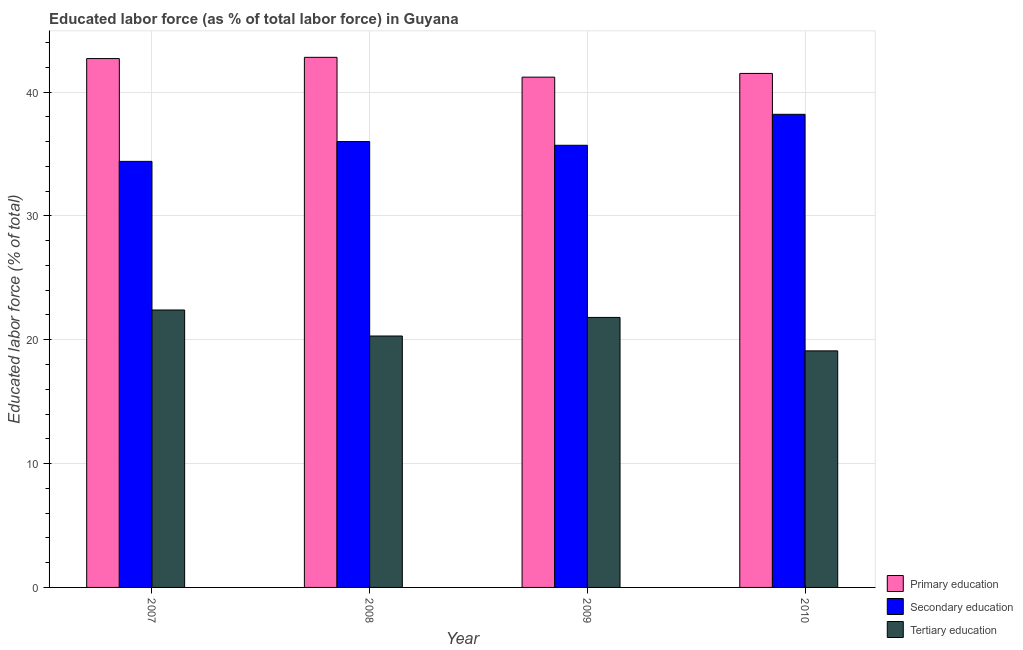How many groups of bars are there?
Your response must be concise. 4. Are the number of bars per tick equal to the number of legend labels?
Provide a short and direct response. Yes. How many bars are there on the 1st tick from the right?
Give a very brief answer. 3. What is the percentage of labor force who received tertiary education in 2008?
Keep it short and to the point. 20.3. Across all years, what is the maximum percentage of labor force who received secondary education?
Provide a succinct answer. 38.2. Across all years, what is the minimum percentage of labor force who received primary education?
Keep it short and to the point. 41.2. In which year was the percentage of labor force who received tertiary education minimum?
Your answer should be very brief. 2010. What is the total percentage of labor force who received primary education in the graph?
Your response must be concise. 168.2. What is the difference between the percentage of labor force who received tertiary education in 2007 and the percentage of labor force who received primary education in 2010?
Provide a succinct answer. 3.3. What is the average percentage of labor force who received secondary education per year?
Keep it short and to the point. 36.08. In the year 2010, what is the difference between the percentage of labor force who received tertiary education and percentage of labor force who received primary education?
Give a very brief answer. 0. What is the ratio of the percentage of labor force who received secondary education in 2007 to that in 2010?
Provide a short and direct response. 0.9. Is the difference between the percentage of labor force who received secondary education in 2009 and 2010 greater than the difference between the percentage of labor force who received primary education in 2009 and 2010?
Offer a very short reply. No. What is the difference between the highest and the second highest percentage of labor force who received primary education?
Your answer should be very brief. 0.1. What is the difference between the highest and the lowest percentage of labor force who received tertiary education?
Give a very brief answer. 3.3. In how many years, is the percentage of labor force who received tertiary education greater than the average percentage of labor force who received tertiary education taken over all years?
Keep it short and to the point. 2. Is the sum of the percentage of labor force who received secondary education in 2008 and 2009 greater than the maximum percentage of labor force who received tertiary education across all years?
Your response must be concise. Yes. What does the 1st bar from the left in 2009 represents?
Ensure brevity in your answer.  Primary education. What does the 1st bar from the right in 2010 represents?
Your response must be concise. Tertiary education. Is it the case that in every year, the sum of the percentage of labor force who received primary education and percentage of labor force who received secondary education is greater than the percentage of labor force who received tertiary education?
Make the answer very short. Yes. How many bars are there?
Ensure brevity in your answer.  12. Are all the bars in the graph horizontal?
Your response must be concise. No. How many years are there in the graph?
Make the answer very short. 4. What is the difference between two consecutive major ticks on the Y-axis?
Your answer should be very brief. 10. Does the graph contain grids?
Your answer should be very brief. Yes. How many legend labels are there?
Offer a terse response. 3. What is the title of the graph?
Offer a very short reply. Educated labor force (as % of total labor force) in Guyana. What is the label or title of the X-axis?
Provide a short and direct response. Year. What is the label or title of the Y-axis?
Your response must be concise. Educated labor force (% of total). What is the Educated labor force (% of total) of Primary education in 2007?
Offer a very short reply. 42.7. What is the Educated labor force (% of total) in Secondary education in 2007?
Offer a terse response. 34.4. What is the Educated labor force (% of total) in Tertiary education in 2007?
Make the answer very short. 22.4. What is the Educated labor force (% of total) in Primary education in 2008?
Make the answer very short. 42.8. What is the Educated labor force (% of total) of Tertiary education in 2008?
Give a very brief answer. 20.3. What is the Educated labor force (% of total) in Primary education in 2009?
Provide a succinct answer. 41.2. What is the Educated labor force (% of total) in Secondary education in 2009?
Provide a succinct answer. 35.7. What is the Educated labor force (% of total) in Tertiary education in 2009?
Keep it short and to the point. 21.8. What is the Educated labor force (% of total) of Primary education in 2010?
Provide a short and direct response. 41.5. What is the Educated labor force (% of total) of Secondary education in 2010?
Give a very brief answer. 38.2. What is the Educated labor force (% of total) of Tertiary education in 2010?
Provide a succinct answer. 19.1. Across all years, what is the maximum Educated labor force (% of total) in Primary education?
Give a very brief answer. 42.8. Across all years, what is the maximum Educated labor force (% of total) of Secondary education?
Keep it short and to the point. 38.2. Across all years, what is the maximum Educated labor force (% of total) of Tertiary education?
Offer a terse response. 22.4. Across all years, what is the minimum Educated labor force (% of total) in Primary education?
Offer a terse response. 41.2. Across all years, what is the minimum Educated labor force (% of total) of Secondary education?
Make the answer very short. 34.4. Across all years, what is the minimum Educated labor force (% of total) in Tertiary education?
Ensure brevity in your answer.  19.1. What is the total Educated labor force (% of total) in Primary education in the graph?
Provide a succinct answer. 168.2. What is the total Educated labor force (% of total) in Secondary education in the graph?
Offer a very short reply. 144.3. What is the total Educated labor force (% of total) in Tertiary education in the graph?
Provide a succinct answer. 83.6. What is the difference between the Educated labor force (% of total) in Primary education in 2007 and that in 2008?
Your answer should be very brief. -0.1. What is the difference between the Educated labor force (% of total) in Secondary education in 2007 and that in 2009?
Your answer should be very brief. -1.3. What is the difference between the Educated labor force (% of total) of Primary education in 2007 and that in 2010?
Offer a very short reply. 1.2. What is the difference between the Educated labor force (% of total) in Primary education in 2008 and that in 2009?
Your answer should be compact. 1.6. What is the difference between the Educated labor force (% of total) of Primary education in 2008 and that in 2010?
Offer a very short reply. 1.3. What is the difference between the Educated labor force (% of total) of Tertiary education in 2008 and that in 2010?
Your response must be concise. 1.2. What is the difference between the Educated labor force (% of total) of Primary education in 2007 and the Educated labor force (% of total) of Tertiary education in 2008?
Give a very brief answer. 22.4. What is the difference between the Educated labor force (% of total) in Primary education in 2007 and the Educated labor force (% of total) in Secondary education in 2009?
Provide a short and direct response. 7. What is the difference between the Educated labor force (% of total) in Primary education in 2007 and the Educated labor force (% of total) in Tertiary education in 2009?
Your response must be concise. 20.9. What is the difference between the Educated labor force (% of total) in Primary education in 2007 and the Educated labor force (% of total) in Secondary education in 2010?
Ensure brevity in your answer.  4.5. What is the difference between the Educated labor force (% of total) in Primary education in 2007 and the Educated labor force (% of total) in Tertiary education in 2010?
Keep it short and to the point. 23.6. What is the difference between the Educated labor force (% of total) in Secondary education in 2007 and the Educated labor force (% of total) in Tertiary education in 2010?
Keep it short and to the point. 15.3. What is the difference between the Educated labor force (% of total) of Primary education in 2008 and the Educated labor force (% of total) of Secondary education in 2009?
Provide a short and direct response. 7.1. What is the difference between the Educated labor force (% of total) in Primary education in 2008 and the Educated labor force (% of total) in Tertiary education in 2009?
Your answer should be very brief. 21. What is the difference between the Educated labor force (% of total) of Primary education in 2008 and the Educated labor force (% of total) of Tertiary education in 2010?
Make the answer very short. 23.7. What is the difference between the Educated labor force (% of total) in Primary education in 2009 and the Educated labor force (% of total) in Secondary education in 2010?
Provide a short and direct response. 3. What is the difference between the Educated labor force (% of total) in Primary education in 2009 and the Educated labor force (% of total) in Tertiary education in 2010?
Provide a succinct answer. 22.1. What is the average Educated labor force (% of total) in Primary education per year?
Offer a very short reply. 42.05. What is the average Educated labor force (% of total) of Secondary education per year?
Give a very brief answer. 36.08. What is the average Educated labor force (% of total) of Tertiary education per year?
Provide a short and direct response. 20.9. In the year 2007, what is the difference between the Educated labor force (% of total) in Primary education and Educated labor force (% of total) in Tertiary education?
Give a very brief answer. 20.3. In the year 2008, what is the difference between the Educated labor force (% of total) of Primary education and Educated labor force (% of total) of Secondary education?
Provide a short and direct response. 6.8. In the year 2008, what is the difference between the Educated labor force (% of total) in Primary education and Educated labor force (% of total) in Tertiary education?
Ensure brevity in your answer.  22.5. In the year 2009, what is the difference between the Educated labor force (% of total) in Secondary education and Educated labor force (% of total) in Tertiary education?
Your answer should be compact. 13.9. In the year 2010, what is the difference between the Educated labor force (% of total) of Primary education and Educated labor force (% of total) of Tertiary education?
Offer a terse response. 22.4. What is the ratio of the Educated labor force (% of total) in Primary education in 2007 to that in 2008?
Provide a succinct answer. 1. What is the ratio of the Educated labor force (% of total) of Secondary education in 2007 to that in 2008?
Provide a short and direct response. 0.96. What is the ratio of the Educated labor force (% of total) of Tertiary education in 2007 to that in 2008?
Your response must be concise. 1.1. What is the ratio of the Educated labor force (% of total) of Primary education in 2007 to that in 2009?
Provide a succinct answer. 1.04. What is the ratio of the Educated labor force (% of total) in Secondary education in 2007 to that in 2009?
Provide a short and direct response. 0.96. What is the ratio of the Educated labor force (% of total) in Tertiary education in 2007 to that in 2009?
Provide a succinct answer. 1.03. What is the ratio of the Educated labor force (% of total) in Primary education in 2007 to that in 2010?
Your answer should be compact. 1.03. What is the ratio of the Educated labor force (% of total) of Secondary education in 2007 to that in 2010?
Give a very brief answer. 0.9. What is the ratio of the Educated labor force (% of total) of Tertiary education in 2007 to that in 2010?
Your answer should be compact. 1.17. What is the ratio of the Educated labor force (% of total) in Primary education in 2008 to that in 2009?
Provide a short and direct response. 1.04. What is the ratio of the Educated labor force (% of total) of Secondary education in 2008 to that in 2009?
Offer a terse response. 1.01. What is the ratio of the Educated labor force (% of total) of Tertiary education in 2008 to that in 2009?
Your response must be concise. 0.93. What is the ratio of the Educated labor force (% of total) in Primary education in 2008 to that in 2010?
Your answer should be very brief. 1.03. What is the ratio of the Educated labor force (% of total) in Secondary education in 2008 to that in 2010?
Offer a terse response. 0.94. What is the ratio of the Educated labor force (% of total) of Tertiary education in 2008 to that in 2010?
Offer a terse response. 1.06. What is the ratio of the Educated labor force (% of total) of Primary education in 2009 to that in 2010?
Ensure brevity in your answer.  0.99. What is the ratio of the Educated labor force (% of total) in Secondary education in 2009 to that in 2010?
Offer a very short reply. 0.93. What is the ratio of the Educated labor force (% of total) of Tertiary education in 2009 to that in 2010?
Your answer should be compact. 1.14. What is the difference between the highest and the lowest Educated labor force (% of total) of Primary education?
Ensure brevity in your answer.  1.6. What is the difference between the highest and the lowest Educated labor force (% of total) of Secondary education?
Your answer should be compact. 3.8. 